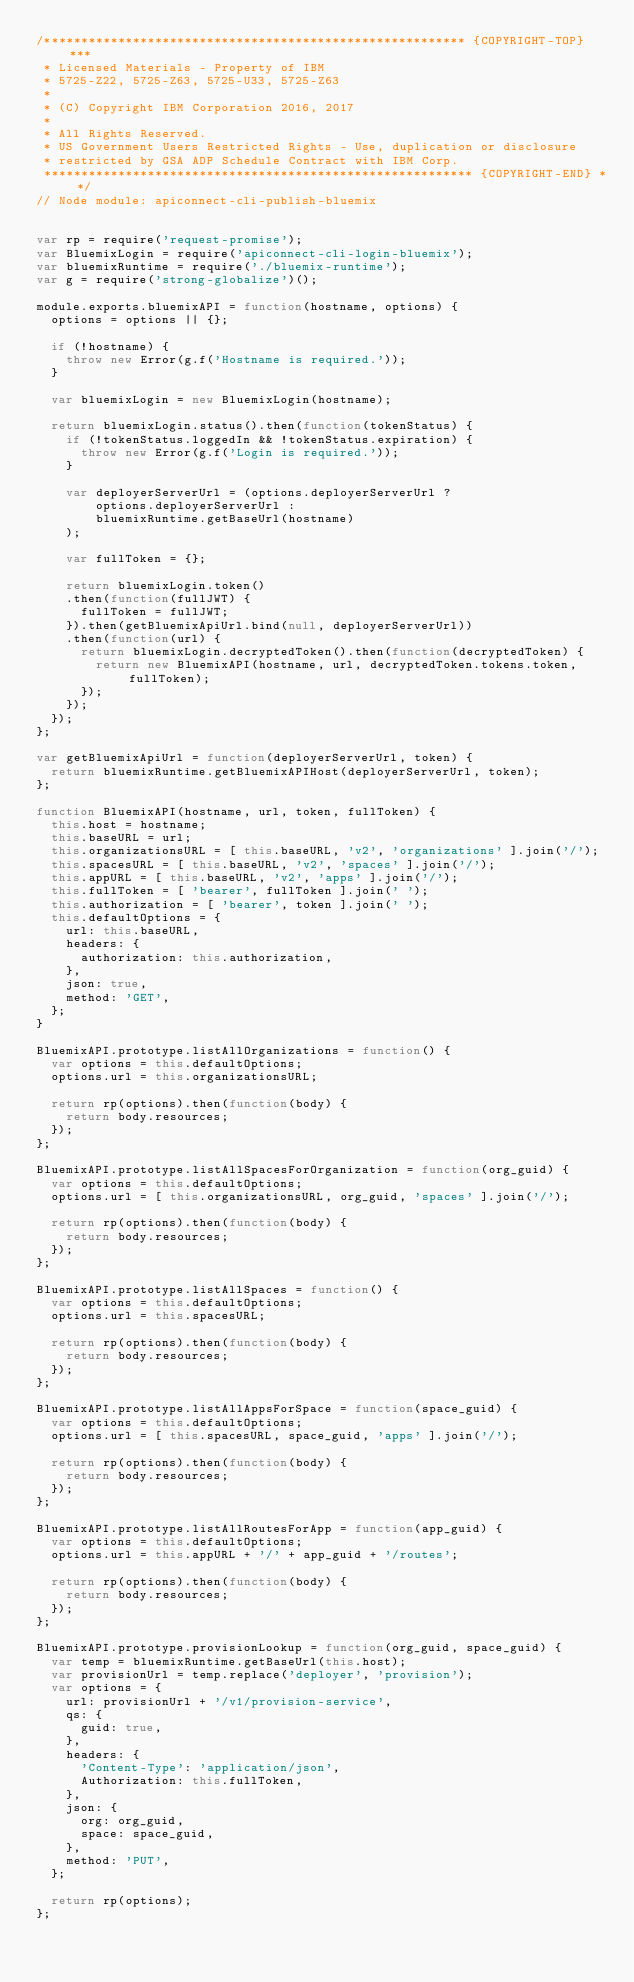<code> <loc_0><loc_0><loc_500><loc_500><_JavaScript_>/********************************************************* {COPYRIGHT-TOP} ***
 * Licensed Materials - Property of IBM
 * 5725-Z22, 5725-Z63, 5725-U33, 5725-Z63
 *
 * (C) Copyright IBM Corporation 2016, 2017
 *
 * All Rights Reserved.
 * US Government Users Restricted Rights - Use, duplication or disclosure
 * restricted by GSA ADP Schedule Contract with IBM Corp.
 ********************************************************** {COPYRIGHT-END} **/
// Node module: apiconnect-cli-publish-bluemix


var rp = require('request-promise');
var BluemixLogin = require('apiconnect-cli-login-bluemix');
var bluemixRuntime = require('./bluemix-runtime');
var g = require('strong-globalize')();

module.exports.bluemixAPI = function(hostname, options) {
  options = options || {};

  if (!hostname) {
    throw new Error(g.f('Hostname is required.'));
  }

  var bluemixLogin = new BluemixLogin(hostname);

  return bluemixLogin.status().then(function(tokenStatus) {
    if (!tokenStatus.loggedIn && !tokenStatus.expiration) {
      throw new Error(g.f('Login is required.'));
    }

    var deployerServerUrl = (options.deployerServerUrl ?
        options.deployerServerUrl :
        bluemixRuntime.getBaseUrl(hostname)
    );

    var fullToken = {};

    return bluemixLogin.token()
    .then(function(fullJWT) {
      fullToken = fullJWT;
    }).then(getBluemixApiUrl.bind(null, deployerServerUrl))
    .then(function(url) {
      return bluemixLogin.decryptedToken().then(function(decryptedToken) {
        return new BluemixAPI(hostname, url, decryptedToken.tokens.token, fullToken);
      });
    });
  });
};

var getBluemixApiUrl = function(deployerServerUrl, token) {
  return bluemixRuntime.getBluemixAPIHost(deployerServerUrl, token);
};

function BluemixAPI(hostname, url, token, fullToken) {
  this.host = hostname;
  this.baseURL = url;
  this.organizationsURL = [ this.baseURL, 'v2', 'organizations' ].join('/');
  this.spacesURL = [ this.baseURL, 'v2', 'spaces' ].join('/');
  this.appURL = [ this.baseURL, 'v2', 'apps' ].join('/');
  this.fullToken = [ 'bearer', fullToken ].join(' ');
  this.authorization = [ 'bearer', token ].join(' ');
  this.defaultOptions = {
    url: this.baseURL,
    headers: {
      authorization: this.authorization,
    },
    json: true,
    method: 'GET',
  };
}

BluemixAPI.prototype.listAllOrganizations = function() {
  var options = this.defaultOptions;
  options.url = this.organizationsURL;

  return rp(options).then(function(body) {
    return body.resources;
  });
};

BluemixAPI.prototype.listAllSpacesForOrganization = function(org_guid) {
  var options = this.defaultOptions;
  options.url = [ this.organizationsURL, org_guid, 'spaces' ].join('/');

  return rp(options).then(function(body) {
    return body.resources;
  });
};

BluemixAPI.prototype.listAllSpaces = function() {
  var options = this.defaultOptions;
  options.url = this.spacesURL;

  return rp(options).then(function(body) {
    return body.resources;
  });
};

BluemixAPI.prototype.listAllAppsForSpace = function(space_guid) {
  var options = this.defaultOptions;
  options.url = [ this.spacesURL, space_guid, 'apps' ].join('/');

  return rp(options).then(function(body) {
    return body.resources;
  });
};

BluemixAPI.prototype.listAllRoutesForApp = function(app_guid) {
  var options = this.defaultOptions;
  options.url = this.appURL + '/' + app_guid + '/routes';

  return rp(options).then(function(body) {
    return body.resources;
  });
};

BluemixAPI.prototype.provisionLookup = function(org_guid, space_guid) {
  var temp = bluemixRuntime.getBaseUrl(this.host);
  var provisionUrl = temp.replace('deployer', 'provision');
  var options = {
    url: provisionUrl + '/v1/provision-service',
    qs: {
      guid: true,
    },
    headers: {
      'Content-Type': 'application/json',
      Authorization: this.fullToken,
    },
    json: {
      org: org_guid,
      space: space_guid,
    },
    method: 'PUT',
  };

  return rp(options);
};

</code> 